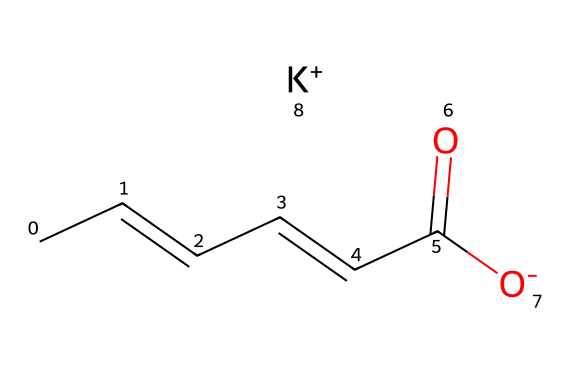What is the IUPAC name of this chemical? The SMILES representation corresponds to a molecule that can be named by analyzing the structure: the longest carbon chain with the specific substituents reveals the IUPAC name as  potassium (E)-hex-2-enedioate.
Answer: potassium (E)-hex-2-enedioate How many carbon atoms are present in the molecular structure? By interpreting the SMILES, we can count the carbon atoms indicated by 'C' in the structure. There are a total of 6 carbon atoms present in the chain.
Answer: 6 What type of chemical bond connects the carbon atoms in this molecule? The structure reveals that the elements in the carbon chain are primarily connected by single bonds, although there is also a double bond indicated between two of the carbon atoms.
Answer: single and double bonds What is the role of potassium in this preservative? In the structure, the potassium ion (K+) serves as a cation that pairs with the anionic part of the molecule (the carboxylate group). This pairing is essential for the molecule's solubility in wine and cheese, which helps in its function as a preservative.
Answer: cation for solubility Which functional group is present in potassium sorbate? The molecular structure features a carboxylate anion, which indicates the presence of the carboxylic acid functional group that has been deprotonated in its salt form.
Answer: carboxylate 